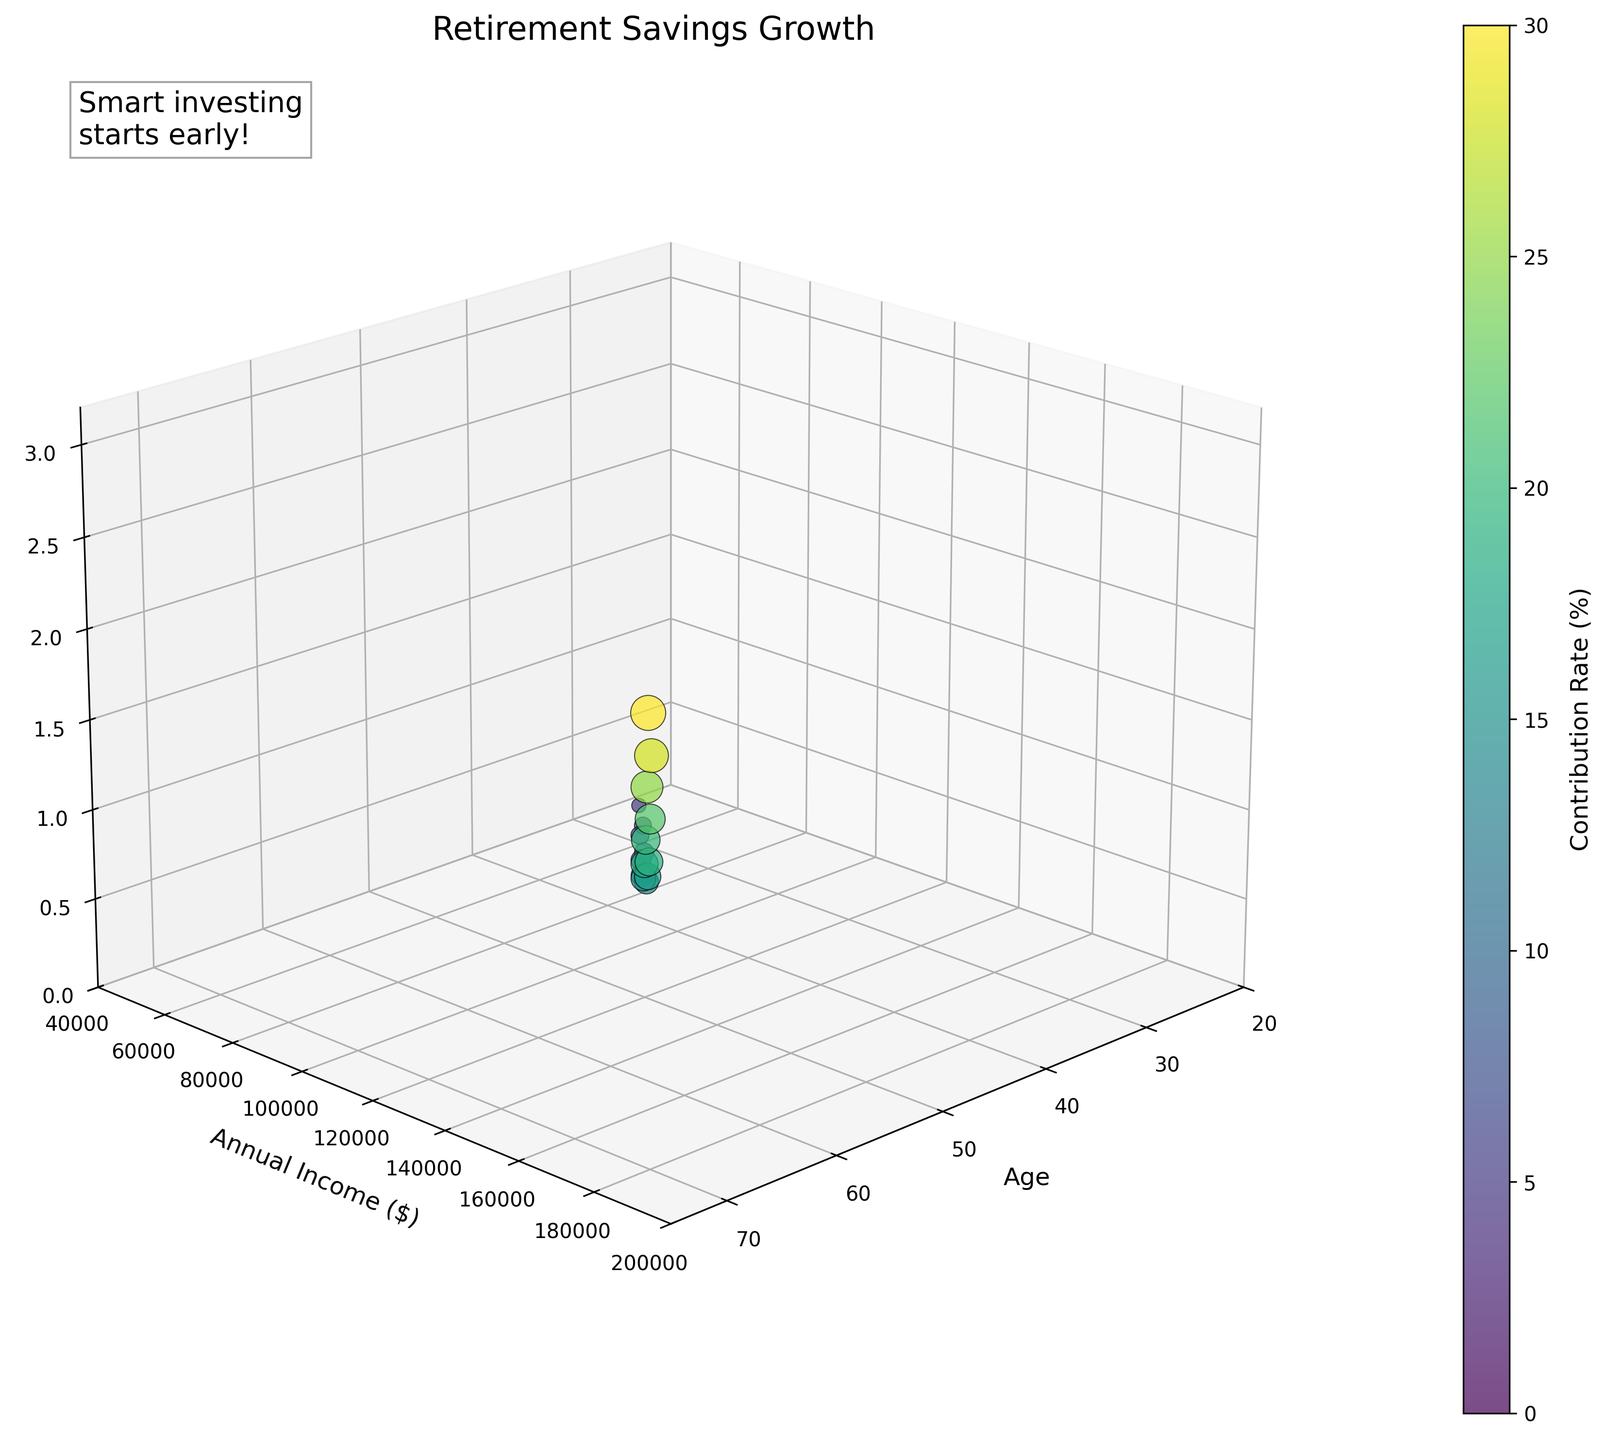What is the title of the figure? The title can be found at the top of the figure. It is a summary of the content the plot represents.
Answer: Retirement Savings Growth Which variable is represented by the x-axis? The x-axis label indicates which variable it represents. It is placed along the horizontal axis of the plot.
Answer: Age How many data points are plotted in total? Each unique data point appears as a distinct marker in the 3D scatter plot. Counting all markers will give the total number of data points.
Answer: 20 What does the color of the data points indicate? The color of the data points is described in the color bar, which is usually located to the side of the plot and provides a color gradient corresponding to a particular variable.
Answer: Contribution Rate (%) At what age does the individual with the highest retirement savings appear, and what is the savings amount? By examining the peak point on the z-axis (Retirement Savings) and matching it with its corresponding age on the x-axis, the answer can be determined.
Answer: 72 years, $3,000,000 Who has a higher annual income: at age 50 or age 60? And by how much? Locate the points corresponding to age 50 and age 60 on the x-axis and compare their y-values (Annual Income). Subtract the lower income from the higher income to find the difference.
Answer: Age 60 by $30,000 Compare the retirement savings at ages 33 and 35. Which age has more savings and by how much? Locate the data points for ages 33 and 35 on the x-axis. Compare their z-values (Retirement Savings) and calculate the difference.
Answer: Age 35 has more by $35,000 How does the contribution rate change from age 58 to age 60? By identifying the colors of the points at age 58 and age 60 and referencing the color bar, determine the contribution rate at each age and observe the change.
Answer: Increases from 22% to 25% What's the difference in retirement savings between ages 70 and 72? Locate the data points for ages 70 and 72 on the x-axis. Compare their z-values (Retirement Savings) and calculate the difference.
Answer: $500,000 What trend do you observe in retirement savings as the contribution rate increases? Observing the data points of differing colors (representing contribution rates) and their corresponding z-values (Retirement Savings) helps identify any trend relationships.
Answer: Savings generally increase with higher contribution rates 